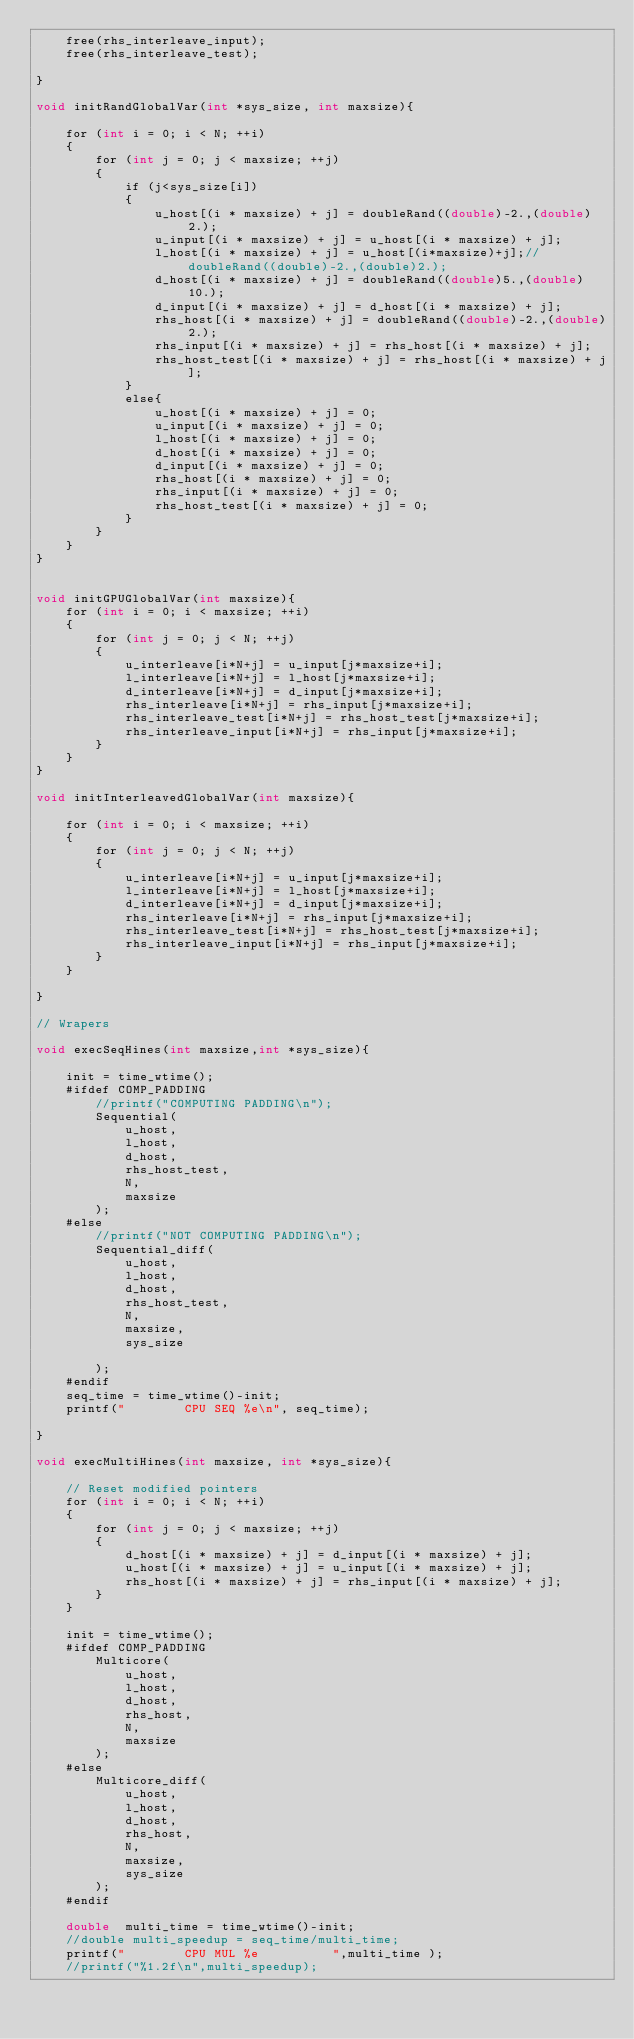Convert code to text. <code><loc_0><loc_0><loc_500><loc_500><_Cuda_>    free(rhs_interleave_input); 
    free(rhs_interleave_test);

}

void initRandGlobalVar(int *sys_size, int maxsize){

    for (int i = 0; i < N; ++i)
    {
        for (int j = 0; j < maxsize; ++j)
        {
            if (j<sys_size[i])
            {
                u_host[(i * maxsize) + j] = doubleRand((double)-2.,(double)2.);
                u_input[(i * maxsize) + j] = u_host[(i * maxsize) + j];
                l_host[(i * maxsize) + j] = u_host[(i*maxsize)+j];//doubleRand((double)-2.,(double)2.);
                d_host[(i * maxsize) + j] = doubleRand((double)5.,(double)10.);
                d_input[(i * maxsize) + j] = d_host[(i * maxsize) + j];
                rhs_host[(i * maxsize) + j] = doubleRand((double)-2.,(double)2.);
                rhs_input[(i * maxsize) + j] = rhs_host[(i * maxsize) + j];
                rhs_host_test[(i * maxsize) + j] = rhs_host[(i * maxsize) + j];
            }
            else{
                u_host[(i * maxsize) + j] = 0;
                u_input[(i * maxsize) + j] = 0;
                l_host[(i * maxsize) + j] = 0;
                d_host[(i * maxsize) + j] = 0;
                d_input[(i * maxsize) + j] = 0;
                rhs_host[(i * maxsize) + j] = 0;
                rhs_input[(i * maxsize) + j] = 0;
                rhs_host_test[(i * maxsize) + j] = 0;
            }
        }
    }
}


void initGPUGlobalVar(int maxsize){
    for (int i = 0; i < maxsize; ++i)
    {
        for (int j = 0; j < N; ++j)
        {
            u_interleave[i*N+j] = u_input[j*maxsize+i];
            l_interleave[i*N+j] = l_host[j*maxsize+i];
            d_interleave[i*N+j] = d_input[j*maxsize+i];
            rhs_interleave[i*N+j] = rhs_input[j*maxsize+i];
            rhs_interleave_test[i*N+j] = rhs_host_test[j*maxsize+i];
            rhs_interleave_input[i*N+j] = rhs_input[j*maxsize+i];
        }
    }
}

void initInterleavedGlobalVar(int maxsize){

    for (int i = 0; i < maxsize; ++i)
    {
        for (int j = 0; j < N; ++j)
        {
            u_interleave[i*N+j] = u_input[j*maxsize+i];
            l_interleave[i*N+j] = l_host[j*maxsize+i];
            d_interleave[i*N+j] = d_input[j*maxsize+i];
            rhs_interleave[i*N+j] = rhs_input[j*maxsize+i];
            rhs_interleave_test[i*N+j] = rhs_host_test[j*maxsize+i];
            rhs_interleave_input[i*N+j] = rhs_input[j*maxsize+i];
        }
    }

}

// Wrapers 

void execSeqHines(int maxsize,int *sys_size){

    init = time_wtime();
    #ifdef COMP_PADDING
        //printf("COMPUTING PADDING\n"); 
        Sequential(
            u_host,
            l_host,
            d_host,
            rhs_host_test,
            N,
            maxsize
        );
    #else
        //printf("NOT COMPUTING PADDING\n"); 
        Sequential_diff(
            u_host,
            l_host,
            d_host,
            rhs_host_test,
            N,
            maxsize,
            sys_size

        );
    #endif
    seq_time = time_wtime()-init;
    printf("        CPU SEQ %e\n", seq_time);

}

void execMultiHines(int maxsize, int *sys_size){
    
	// Reset modified pointers
    for (int i = 0; i < N; ++i)
	{
        for (int j = 0; j < maxsize; ++j)
        {
            d_host[(i * maxsize) + j] = d_input[(i * maxsize) + j];
            u_host[(i * maxsize) + j] = u_input[(i * maxsize) + j];
            rhs_host[(i * maxsize) + j] = rhs_input[(i * maxsize) + j];
		}
	}
        
    init = time_wtime();
    #ifdef COMP_PADDING
        Multicore(
            u_host,
            l_host,
            d_host,
            rhs_host,
            N,
            maxsize
        );
    #else
        Multicore_diff(
            u_host,
            l_host,
            d_host,
            rhs_host,
            N,
            maxsize,
            sys_size
		);
	#endif

    double  multi_time = time_wtime()-init;
    //double multi_speedup = seq_time/multi_time;
    printf("        CPU MUL %e          ",multi_time );
    //printf("%1.2f\n",multi_speedup);</code> 